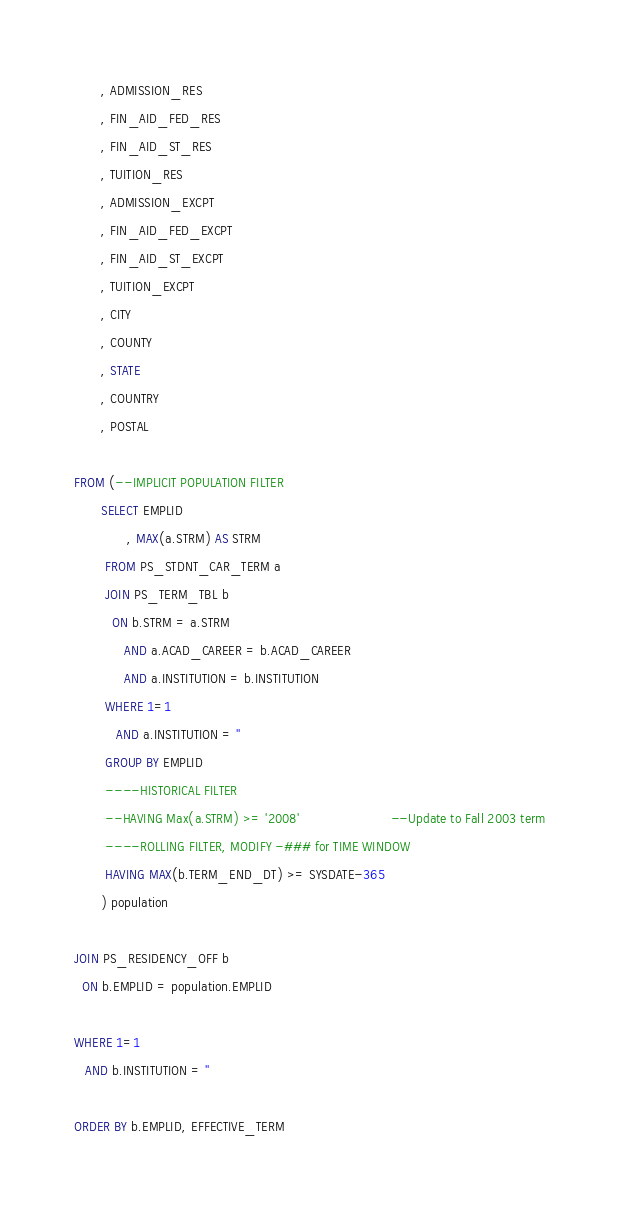Convert code to text. <code><loc_0><loc_0><loc_500><loc_500><_SQL_>       , ADMISSION_RES
       , FIN_AID_FED_RES
       , FIN_AID_ST_RES
       , TUITION_RES
       , ADMISSION_EXCPT
       , FIN_AID_FED_EXCPT
       , FIN_AID_ST_EXCPT
       , TUITION_EXCPT
       , CITY
       , COUNTY
       , STATE
       , COUNTRY
       , POSTAL

FROM (--IMPLICIT POPULATION FILTER 
       SELECT EMPLID 
              , MAX(a.STRM) AS STRM 
        FROM PS_STDNT_CAR_TERM a 
	    JOIN PS_TERM_TBL b 
		  ON b.STRM = a.STRM 
			 AND a.ACAD_CAREER = b.ACAD_CAREER
			 AND a.INSTITUTION = b.INSTITUTION
        WHERE 1=1
		   AND a.INSTITUTION = ''
        GROUP BY EMPLID 
        ----HISTORICAL FILTER 
        --HAVING Max(a.STRM) >= '2008'                        --Update to Fall 2003 term
        ----ROLLING FILTER, MODIFY -### for TIME WINDOW 
        HAVING MAX(b.TERM_END_DT) >= SYSDATE-365 
       ) population 	

JOIN PS_RESIDENCY_OFF b
  ON b.EMPLID = population.EMPLID

WHERE 1=1
   AND b.INSTITUTION = ''

ORDER BY b.EMPLID, EFFECTIVE_TERM
</code> 